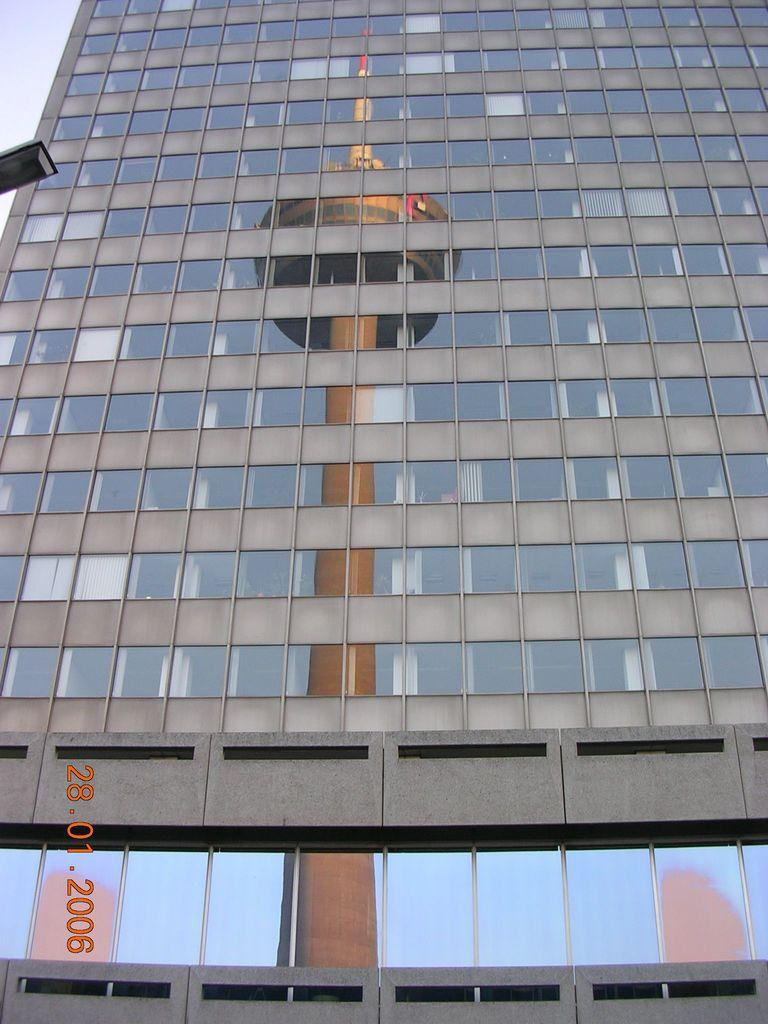What type of building is depicted in the image? The building in the image has glass walls. What can be seen reflected in the glass walls of the building? The building has a reflection of a tower. Is there any additional information about the image itself? Yes, there is a watermark in the left bottom corner of the image. How many legs can be seen on the glass in the image? There are no legs visible in the image, as the main subject is a building with glass walls, and glass does not have legs. 